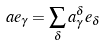Convert formula to latex. <formula><loc_0><loc_0><loc_500><loc_500>a e _ { \gamma } = \sum _ { \delta } a _ { \gamma } ^ { \delta } e _ { \delta }</formula> 